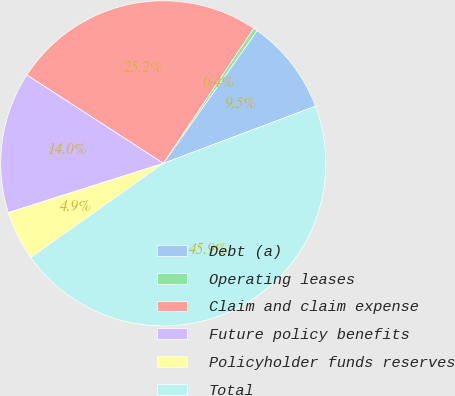<chart> <loc_0><loc_0><loc_500><loc_500><pie_chart><fcel>Debt (a)<fcel>Operating leases<fcel>Claim and claim expense<fcel>Future policy benefits<fcel>Policyholder funds reserves<fcel>Total<nl><fcel>9.49%<fcel>0.4%<fcel>25.24%<fcel>14.04%<fcel>4.94%<fcel>45.88%<nl></chart> 